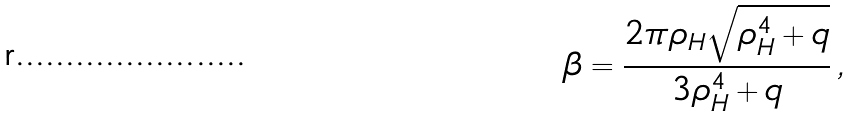<formula> <loc_0><loc_0><loc_500><loc_500>\beta = \frac { 2 \pi \rho _ { H } \sqrt { \rho _ { H } ^ { 4 } + q } } { 3 \rho _ { H } ^ { 4 } + q } \, ,</formula> 